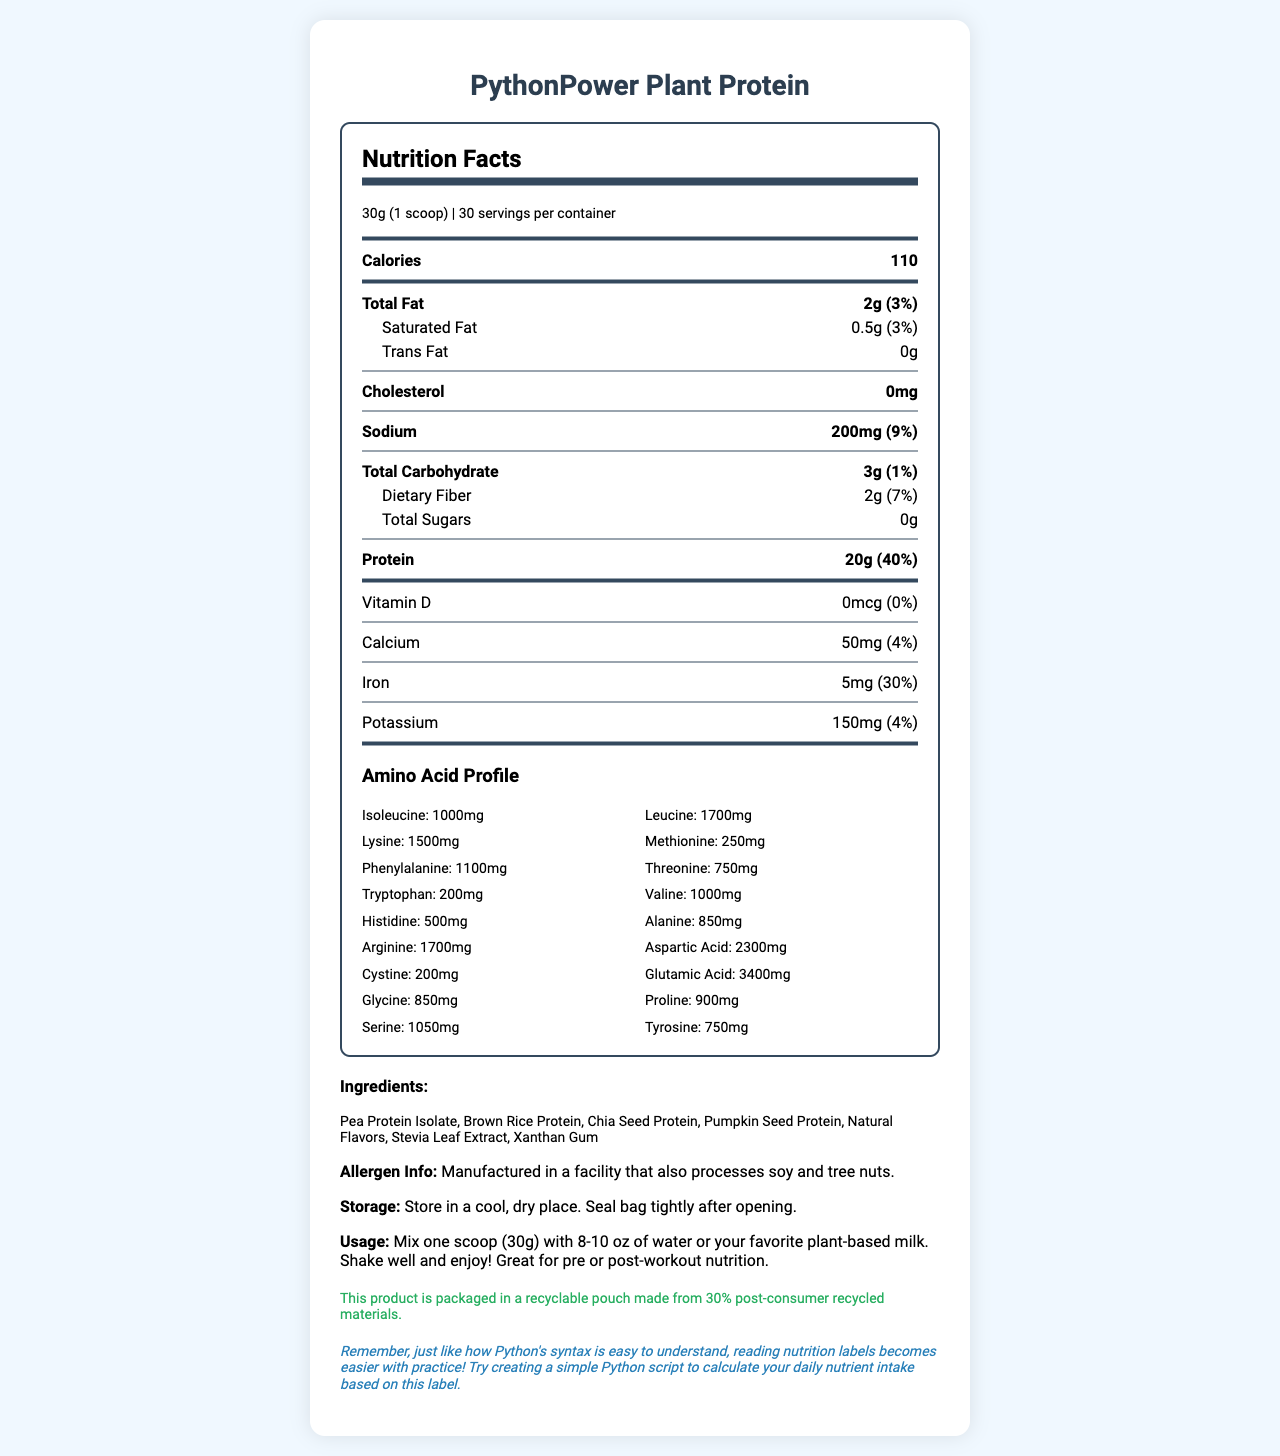what is the serving size of PythonPower Plant Protein? The serving size is mentioned at the top of the nutrition facts section as "30g (1 scoop)".
Answer: 30g (1 scoop) how many calories are in one serving? The calories per serving are listed as 110 in the nutrition document.
Answer: 110 how much protein does one serving contain? The protein amount per serving is mentioned as 20g in the nutrition document.
Answer: 20g what is the total fat content in one serving and its daily value percentage? The total fat content is 2g and the daily value percentage is 3%, as mentioned in the document.
Answer: 2g (3%) what is the main ingredient in PythonPower Plant Protein? The first ingredient listed is Pea Protein Isolate, indicating it is the main ingredient.
Answer: Pea Protein Isolate which of the following amino acids is present in the highest amount? A. Lysine B. Isoleucine C. Leucine D. Methionine The amino acid profile lists Leucine as having 1700mg, which is higher than the amounts for Lysine (1500mg), Isoleucine (1000mg), and Methionine (250mg).
Answer: C what is the daily value percentage of iron in one serving? A. 4% B. 30% C. 7% D. 9% The document states that the daily value percentage of iron is 30%, making option B correct.
Answer: B is there any cholesterol in PythonPower Plant Protein? The document specifies that the cholesterol content is 0mg, indicating no cholesterol is present.
Answer: No describe the main idea of the document The document is focused on delivering comprehensive nutritional information and guidelines for the PythonPower Plant Protein product.
Answer: The document provides detailed nutrition facts for PythonPower Plant Protein, including serving size, calorie count, macronutrients, specific amino acid profile, ingredients, allergen information, usage and storage instructions, and eco-friendly packaging details. what is the source of sweetness in PythonPower Plant Protein? The ingredients list includes Stevia Leaf Extract, indicating it is the source of sweetness.
Answer: Stevia Leaf Extract is the packaging of PythonPower Plant Protein eco-friendly? The document states that the product is packaged in a recyclable pouch made from 30% post-consumer recycled materials, making it eco-friendly.
Answer: Yes how many milligrams of potassium are present in one serving? The document specifies that there are 150mg of potassium in one serving.
Answer: 150mg what should you do to prepare a serving of the protein powder? The usage instructions provide these steps to prepare a serving of the protein powder.
Answer: Mix one scoop (30g) with 8-10 oz of water or your favorite plant-based milk. Shake well and enjoy! can you determine the cost of PythonPower Plant Protein from the document? The document does not provide any information regarding the cost of the protein powder.
Answer: Cannot be determined 